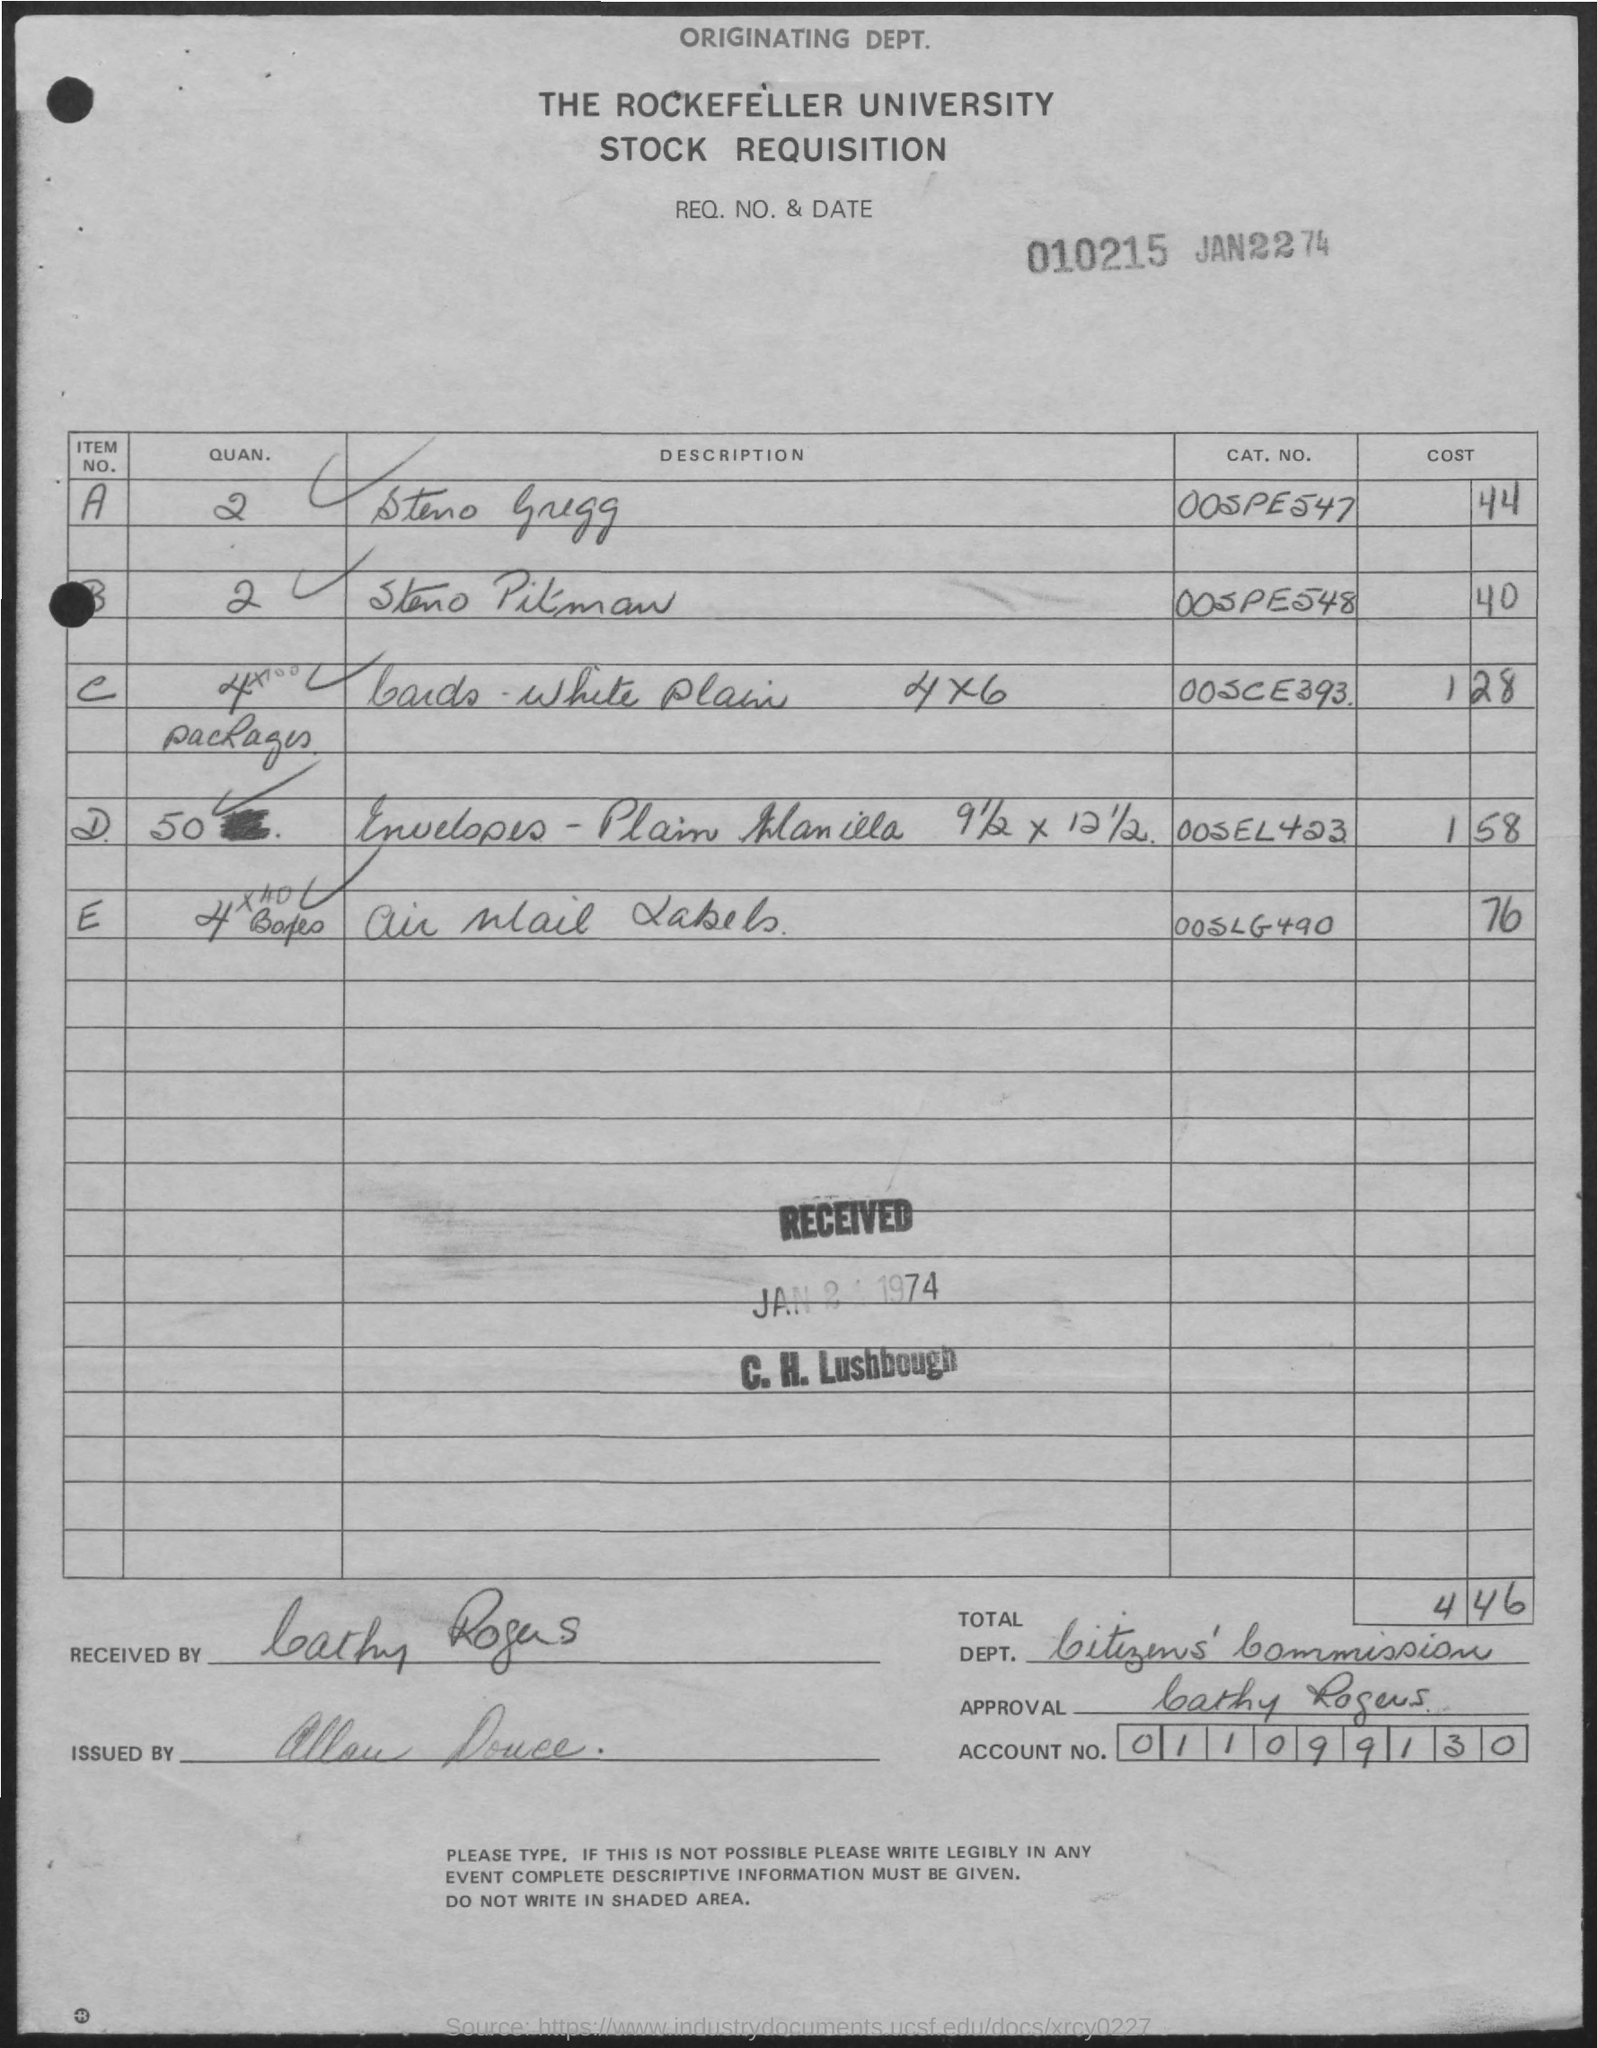Draw attention to some important aspects in this diagram. The cost of Steri Pitman is 40.. What is the total cost of the items requested? What is the account number that has been mentioned? It is 011099130... The quantity of envelopes is 50. 